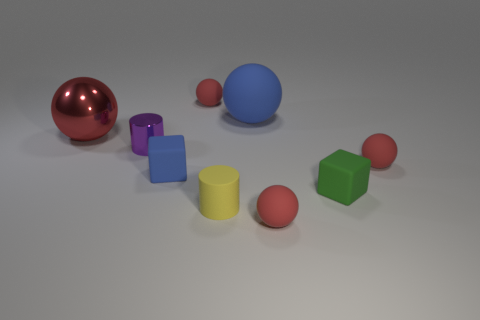There is another object that is the same shape as the small yellow rubber object; what is its color?
Provide a short and direct response. Purple. What is the material of the large sphere on the left side of the yellow cylinder?
Your answer should be very brief. Metal. The large shiny ball has what color?
Your answer should be very brief. Red. There is a cylinder that is behind the green cube; does it have the same size as the yellow rubber cylinder?
Provide a short and direct response. Yes. What is the blue object that is in front of the large sphere on the right side of the shiny object on the right side of the red metal sphere made of?
Make the answer very short. Rubber. Do the large ball that is to the left of the small purple object and the tiny ball in front of the blue rubber cube have the same color?
Your answer should be very brief. Yes. There is a ball to the left of the cylinder on the left side of the small blue thing; what is its material?
Keep it short and to the point. Metal. What color is the rubber cylinder that is the same size as the green matte object?
Your answer should be compact. Yellow. There is a green object; does it have the same shape as the blue thing that is in front of the shiny ball?
Provide a succinct answer. Yes. The object that is the same color as the big matte ball is what shape?
Your response must be concise. Cube. 